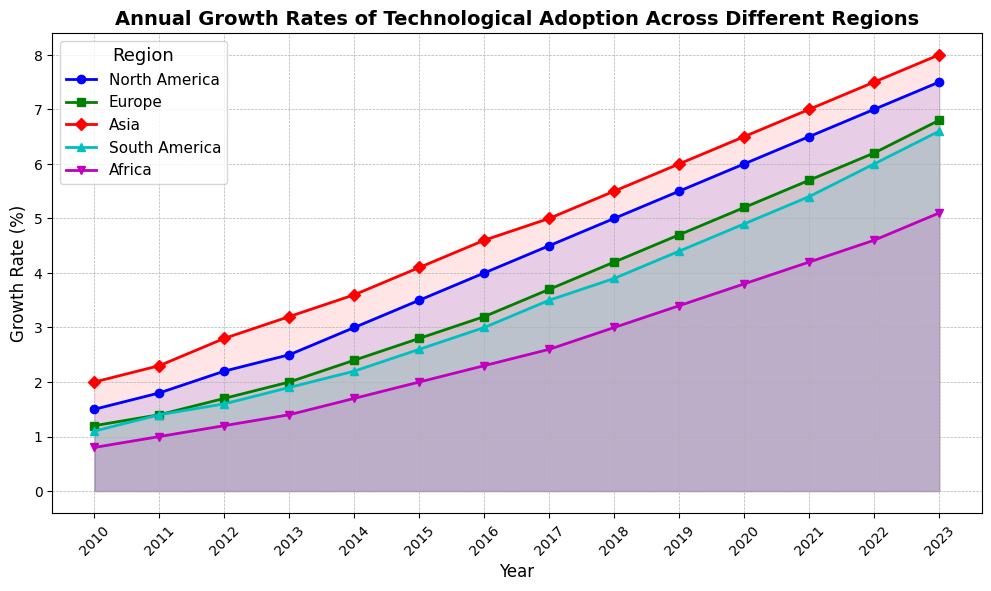What's the range of growth rates in North America over the period shown? To determine the range, we subtract the minimum growth rate from the maximum growth rate for North America. The minimum is 1.5% (2010) and the maximum is 7.5% (2023), so the range is 7.5 - 1.5 = 6.0%
Answer: 6.0% Which region had the highest growth rate in 2023? By examining the graph for 2023, we compare the final points for all the regions: North America (7.5%), Europe (6.8%), Asia (8.0%), South America (6.6%), and Africa (5.1%). Asia has the highest growth rate at 8.0%
Answer: Asia What is the average annual growth rate in Europe from 2010 to 2023? Sum the annual growth rates from 2010 to 2023 for Europe: 1.2 + 1.4 + 1.7 + 2.0 + 2.4 + 2.8 + 3.2 + 3.7 + 4.2 + 4.7 + 5.2 + 5.7 + 6.2 + 6.8 = 51.4. Divide by the number of years (14), the average is 51.4 / 14 = 3.67%
Answer: 3.67% How does the growth rate in Africa compare with South America in 2015? Checking the values for 2015, Africa's growth rate is 2.0% and South America's is 2.6%. Consequently, South America's growth rate is higher than Africa's
Answer: South America is higher Which region showed the consistent increase every year from 2010 to 2023? By examining the upward trend lines in the graph, all regions show consistent annual increases
Answer: All regions What is the total increase in growth rate for Asia from 2010 to 2023? The total increase is calculated by subtracting the growth rate in 2010 from that in 2023 for Asia: 8.0% - 2.0% = 6.0%
Answer: 6.0% In which year did North America's growth rate surpass 5% for the first time? North America's growth rate surpasses 5% for the first time in 2018. This is clear from examining the progression of the graph where North America's line crosses 5% in 2018
Answer: 2018 Compare the growth rate trends between Europe and Asia. Which region saw greater growth over the period? To compare, we subtract the initial growth rates from the final ones for both regions: Europe (6.8 - 1.2 = 5.6%), Asia (8.0 - 2.0 = 6.0%). Asia experienced a higher increase compared to Europe
Answer: Asia What is the visual style used to represent data for South America in the chart? South America is represented by a cyan line with triangles as markers and filled area with a light cyan color under the line
Answer: Cyan line with triangles What is the difference in growth rates between North America and Africa in 2023? Subtract Africa's growth rate from North America's in 2023: 7.5% - 5.1% = 2.4%
Answer: 2.4% 